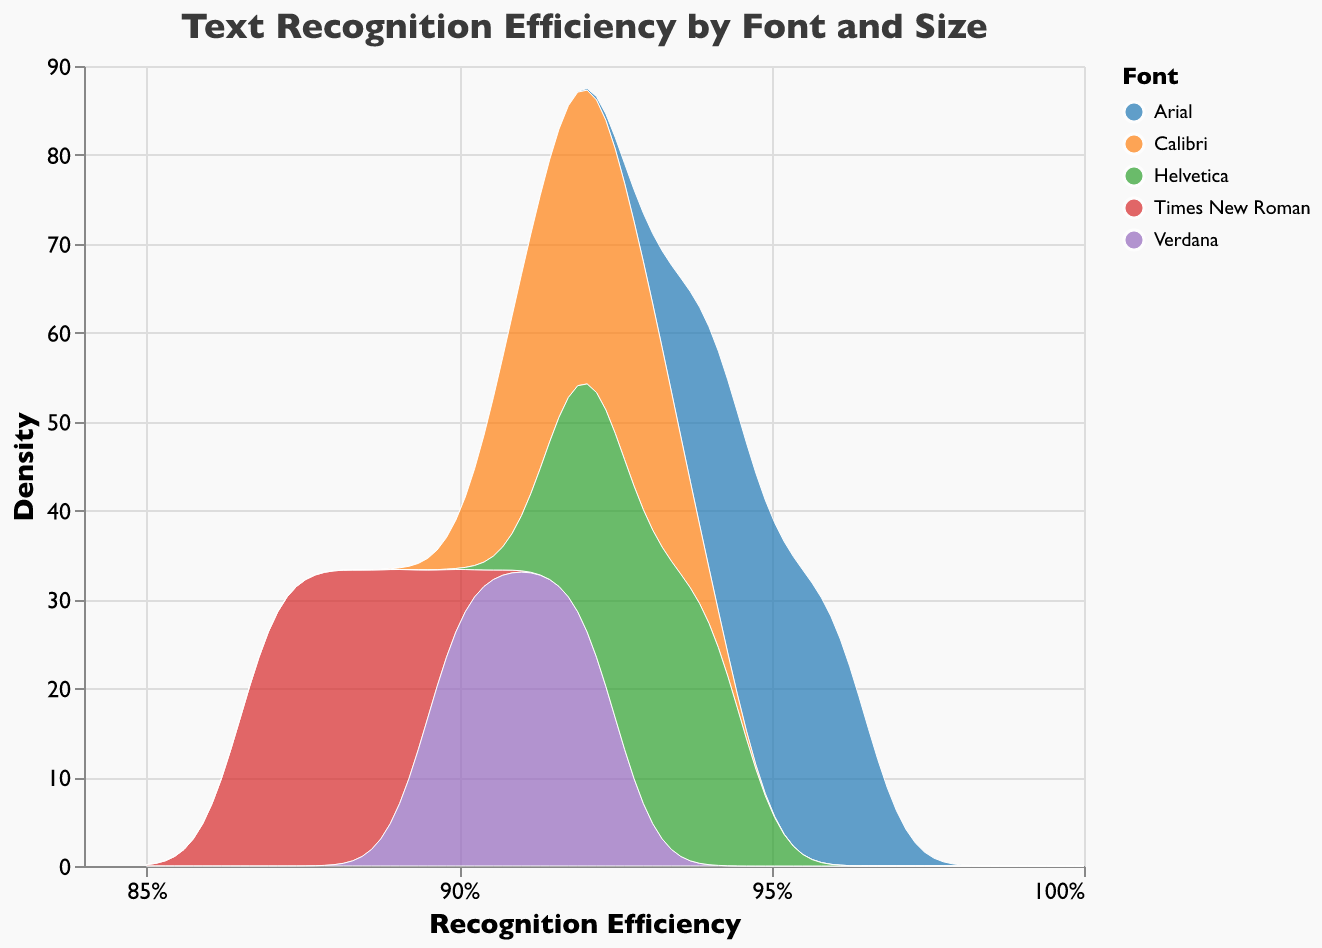What is the highest recognition efficiency observed for Arial font? The plot shows density distributions for recognition efficiency by font. The Arial font curve will reach the farthest on the x-axis, hitting a maximum recognition efficiency value directly from the density plot.
Answer: 0.96 Which font has the lowest recognition efficiency? Comparing the density plots for each font along the x-axis, the lowest value along the recognition efficiency axis belongs to Times New Roman.
Answer: Times New Roman What is the average recognition efficiency for documents with Helvetica font? To find the average, we'll observe the individual peaks in the density plot for the three Helvetica samples (Contract, Invoice, Brochure) and average them: (0.93 + 0.94 + 0.92)/3 = 0.93.
Answer: 0.93 How does the density peak for Arial font compare to Calibri font? The density peaks visually indicate where the majority of data points lie; observe the height of the density plot for Arial and Calibri. Arial has a higher and narrower peak compared to Calibri, indicating it's more consistently high.
Answer: Arial has a higher peak Which font shows the most variation in recognition efficiency? Greater spread or width on the x-axis in the density plot suggests higher variation. Times New Roman shows the broadest curve, indicating the most variation in recognition efficiency.
Answer: Times New Roman Is there a significant difference between the peaks of Helvetica and Verdana fonts in the density plot? Density peaks provide a clear visual difference or similarity between distributions; comparing peaks for Helvetica and Verdana on the plot, they show minor differences, with Helvetica slightly higher.
Answer: Minor difference Which font has the highest density at the top recognition efficiency mark? Examine the very end of the x-axis at the highest recognition efficiency noted and see which density plot reaches highest; Arial and Helvetica are both high, but Arial is slightly higher.
Answer: Arial What common pattern can be identified from the density plots regarding font size? Visually scanning the density plots for each font, smaller size (10) documents cluster more within higher recognition efficiency values compared to larger sizes (12, 14).
Answer: Smaller sizes are more efficient How do the densities of Calibri and Verdana compare at a recognition efficiency of 0.92? Looking at the density plots' intersection with a vertical line at 0.92 on the x-axis shows the heights of Calibri and Verdana; Verdana is higher indicating a higher probability of 0.92 recognition efficiency.
Answer: Verdana is higher Which document type seems to have generally higher recognition efficiency based on the provided data (assuming the document type relates to size trend)? Contracts and Invoices (sizes 10 and 12) generally show higher efficiency than Brochures (14), visible through consistent density trends across fonts.
Answer: Contract and Invoice 